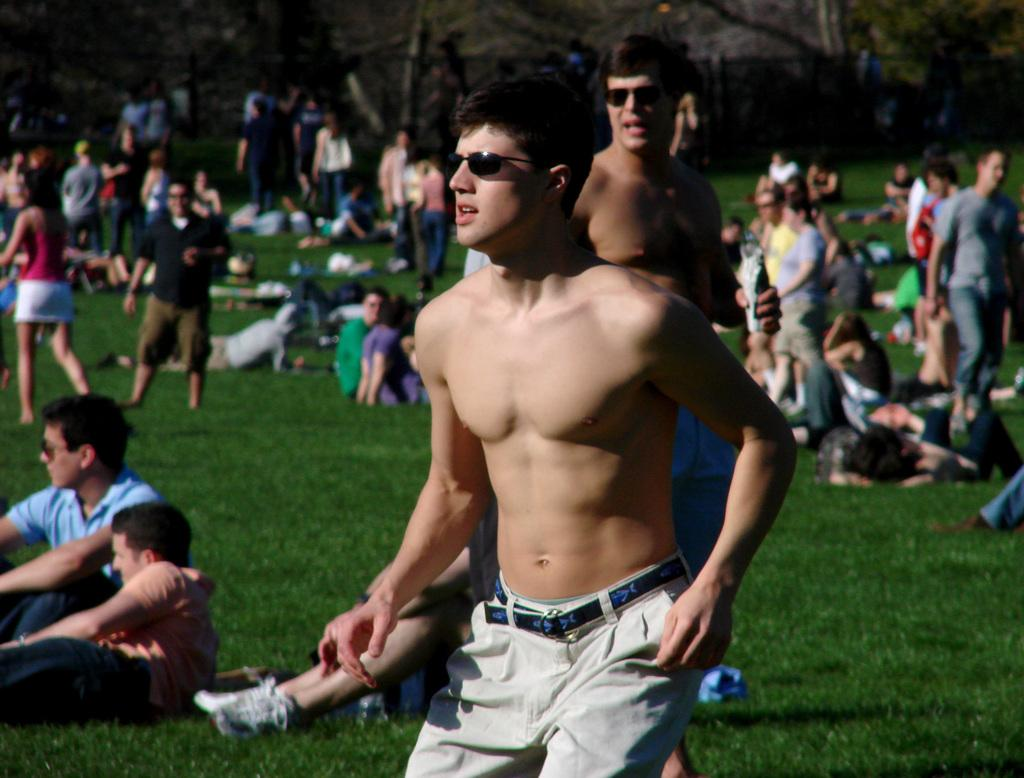What is the main subject of the image? The main subject of the image is a group of people. Can you describe the positions of the people in the image? Some people are sitting, while others are standing. What is the person in front wearing? The person in front is wearing cream-colored pants. What can be seen in the background of the image? There are trees visible in the background of the image. What is the color of the trees in the image? The trees are green in color. What type of hen can be seen in the image? There is no hen present in the image; it features a group of people with trees in the background. What year is depicted in the image? The image does not depict a specific year; it is a snapshot of a moment in time. 